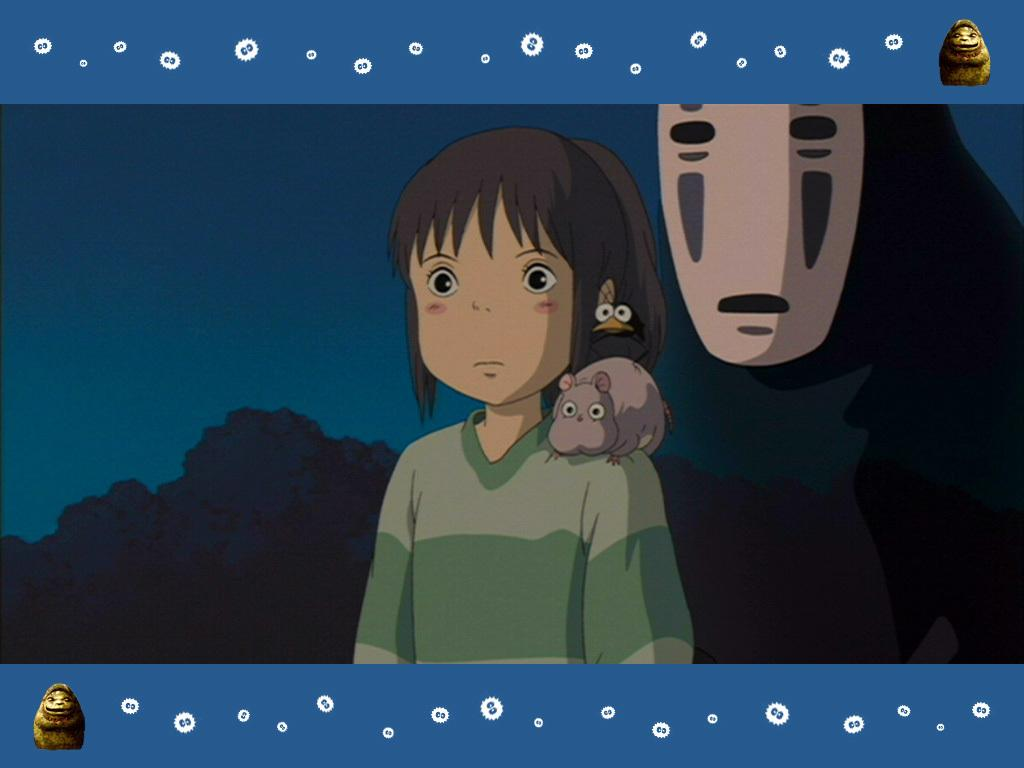What type of character is depicted in the image? There is a cartoon character of a girl in the image. Are there any other characters in the image besides the girl? Yes, there are cartoon characters of animals in the image. What type of system is used to cook the egg in the image? There is no egg present in the image, so it is not possible to determine what type of system might be used to cook it. 